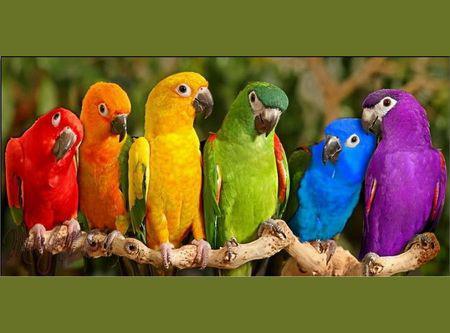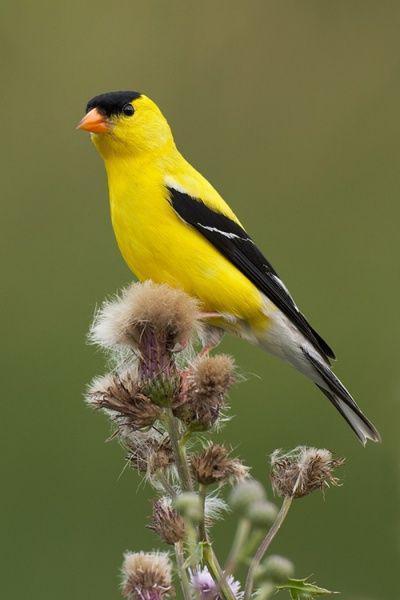The first image is the image on the left, the second image is the image on the right. For the images displayed, is the sentence "There are three birds" factually correct? Answer yes or no. No. 